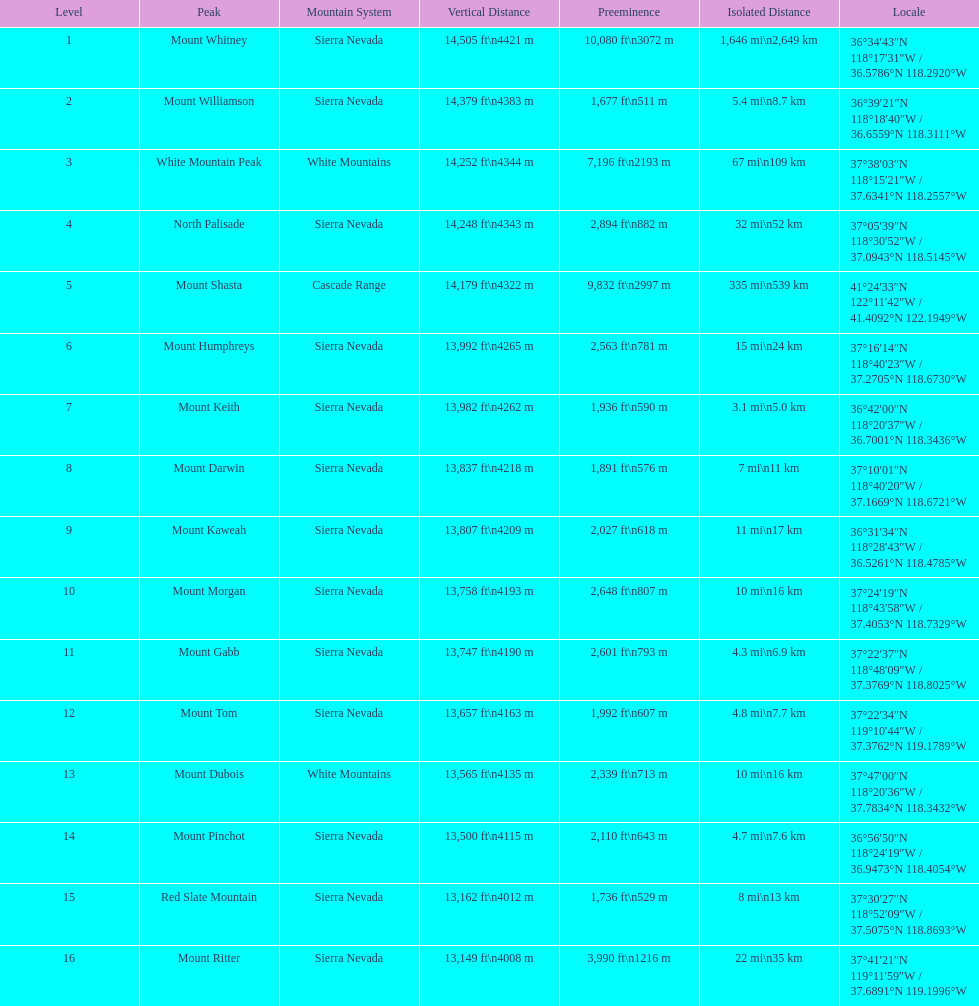Which mountain is higher, mount humphreys or mount kaweah? Mount Humphreys. Parse the full table. {'header': ['Level', 'Peak', 'Mountain System', 'Vertical Distance', 'Preeminence', 'Isolated Distance', 'Locale'], 'rows': [['1', 'Mount Whitney', 'Sierra Nevada', '14,505\xa0ft\\n4421\xa0m', '10,080\xa0ft\\n3072\xa0m', '1,646\xa0mi\\n2,649\xa0km', '36°34′43″N 118°17′31″W\ufeff / \ufeff36.5786°N 118.2920°W'], ['2', 'Mount Williamson', 'Sierra Nevada', '14,379\xa0ft\\n4383\xa0m', '1,677\xa0ft\\n511\xa0m', '5.4\xa0mi\\n8.7\xa0km', '36°39′21″N 118°18′40″W\ufeff / \ufeff36.6559°N 118.3111°W'], ['3', 'White Mountain Peak', 'White Mountains', '14,252\xa0ft\\n4344\xa0m', '7,196\xa0ft\\n2193\xa0m', '67\xa0mi\\n109\xa0km', '37°38′03″N 118°15′21″W\ufeff / \ufeff37.6341°N 118.2557°W'], ['4', 'North Palisade', 'Sierra Nevada', '14,248\xa0ft\\n4343\xa0m', '2,894\xa0ft\\n882\xa0m', '32\xa0mi\\n52\xa0km', '37°05′39″N 118°30′52″W\ufeff / \ufeff37.0943°N 118.5145°W'], ['5', 'Mount Shasta', 'Cascade Range', '14,179\xa0ft\\n4322\xa0m', '9,832\xa0ft\\n2997\xa0m', '335\xa0mi\\n539\xa0km', '41°24′33″N 122°11′42″W\ufeff / \ufeff41.4092°N 122.1949°W'], ['6', 'Mount Humphreys', 'Sierra Nevada', '13,992\xa0ft\\n4265\xa0m', '2,563\xa0ft\\n781\xa0m', '15\xa0mi\\n24\xa0km', '37°16′14″N 118°40′23″W\ufeff / \ufeff37.2705°N 118.6730°W'], ['7', 'Mount Keith', 'Sierra Nevada', '13,982\xa0ft\\n4262\xa0m', '1,936\xa0ft\\n590\xa0m', '3.1\xa0mi\\n5.0\xa0km', '36°42′00″N 118°20′37″W\ufeff / \ufeff36.7001°N 118.3436°W'], ['8', 'Mount Darwin', 'Sierra Nevada', '13,837\xa0ft\\n4218\xa0m', '1,891\xa0ft\\n576\xa0m', '7\xa0mi\\n11\xa0km', '37°10′01″N 118°40′20″W\ufeff / \ufeff37.1669°N 118.6721°W'], ['9', 'Mount Kaweah', 'Sierra Nevada', '13,807\xa0ft\\n4209\xa0m', '2,027\xa0ft\\n618\xa0m', '11\xa0mi\\n17\xa0km', '36°31′34″N 118°28′43″W\ufeff / \ufeff36.5261°N 118.4785°W'], ['10', 'Mount Morgan', 'Sierra Nevada', '13,758\xa0ft\\n4193\xa0m', '2,648\xa0ft\\n807\xa0m', '10\xa0mi\\n16\xa0km', '37°24′19″N 118°43′58″W\ufeff / \ufeff37.4053°N 118.7329°W'], ['11', 'Mount Gabb', 'Sierra Nevada', '13,747\xa0ft\\n4190\xa0m', '2,601\xa0ft\\n793\xa0m', '4.3\xa0mi\\n6.9\xa0km', '37°22′37″N 118°48′09″W\ufeff / \ufeff37.3769°N 118.8025°W'], ['12', 'Mount Tom', 'Sierra Nevada', '13,657\xa0ft\\n4163\xa0m', '1,992\xa0ft\\n607\xa0m', '4.8\xa0mi\\n7.7\xa0km', '37°22′34″N 119°10′44″W\ufeff / \ufeff37.3762°N 119.1789°W'], ['13', 'Mount Dubois', 'White Mountains', '13,565\xa0ft\\n4135\xa0m', '2,339\xa0ft\\n713\xa0m', '10\xa0mi\\n16\xa0km', '37°47′00″N 118°20′36″W\ufeff / \ufeff37.7834°N 118.3432°W'], ['14', 'Mount Pinchot', 'Sierra Nevada', '13,500\xa0ft\\n4115\xa0m', '2,110\xa0ft\\n643\xa0m', '4.7\xa0mi\\n7.6\xa0km', '36°56′50″N 118°24′19″W\ufeff / \ufeff36.9473°N 118.4054°W'], ['15', 'Red Slate Mountain', 'Sierra Nevada', '13,162\xa0ft\\n4012\xa0m', '1,736\xa0ft\\n529\xa0m', '8\xa0mi\\n13\xa0km', '37°30′27″N 118°52′09″W\ufeff / \ufeff37.5075°N 118.8693°W'], ['16', 'Mount Ritter', 'Sierra Nevada', '13,149\xa0ft\\n4008\xa0m', '3,990\xa0ft\\n1216\xa0m', '22\xa0mi\\n35\xa0km', '37°41′21″N 119°11′59″W\ufeff / \ufeff37.6891°N 119.1996°W']]} 